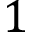<formula> <loc_0><loc_0><loc_500><loc_500>1</formula> 